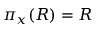Convert formula to latex. <formula><loc_0><loc_0><loc_500><loc_500>\pi _ { x } ( R ) = R</formula> 